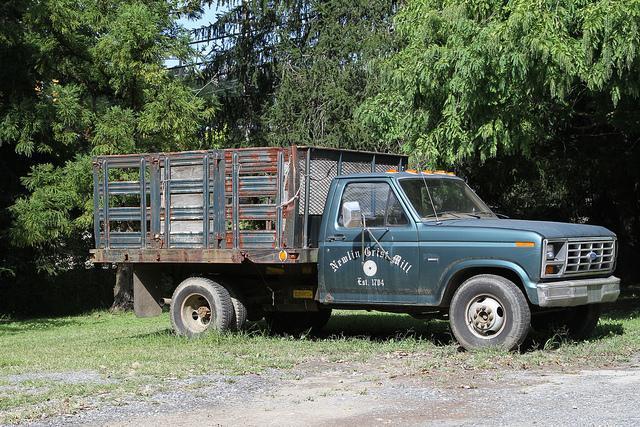How many tires are on the green truck?
Give a very brief answer. 6. How many tires can you see?
Give a very brief answer. 3. How many lights are on the truck?
Give a very brief answer. 2. How many wheels does the green truck have?
Give a very brief answer. 6. 